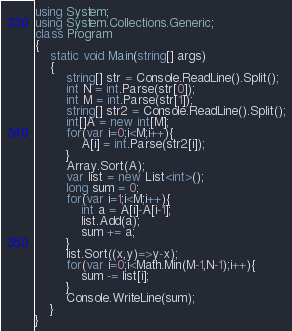Convert code to text. <code><loc_0><loc_0><loc_500><loc_500><_C#_>using System;
using System.Collections.Generic;
class Program
{
	static void Main(string[] args)
	{
		string[] str = Console.ReadLine().Split();
		int N = int.Parse(str[0]);
		int M = int.Parse(str[1]);
		string[] str2 = Console.ReadLine().Split();
		int[]A = new int[M];
		for(var i=0;i<M;i++){
			A[i] = int.Parse(str2[i]);
		}
		Array.Sort(A);
		var list = new List<int>();
		long sum = 0;
		for(var i=1;i<M;i++){
			int a = A[i]-A[i-1];
			list.Add(a);
			sum += a;
		}
		list.Sort((x,y)=>y-x);
		for(var i=0;i<Math.Min(M-1,N-1);i++){
			sum -= list[i];
		}
		Console.WriteLine(sum);
	}
}</code> 